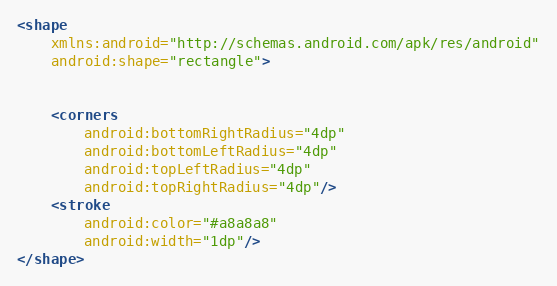Convert code to text. <code><loc_0><loc_0><loc_500><loc_500><_XML_><shape
    xmlns:android="http://schemas.android.com/apk/res/android"
    android:shape="rectangle">


    <corners
        android:bottomRightRadius="4dp"
        android:bottomLeftRadius="4dp"
        android:topLeftRadius="4dp"
        android:topRightRadius="4dp"/>
    <stroke
        android:color="#a8a8a8"
        android:width="1dp"/>
</shape></code> 